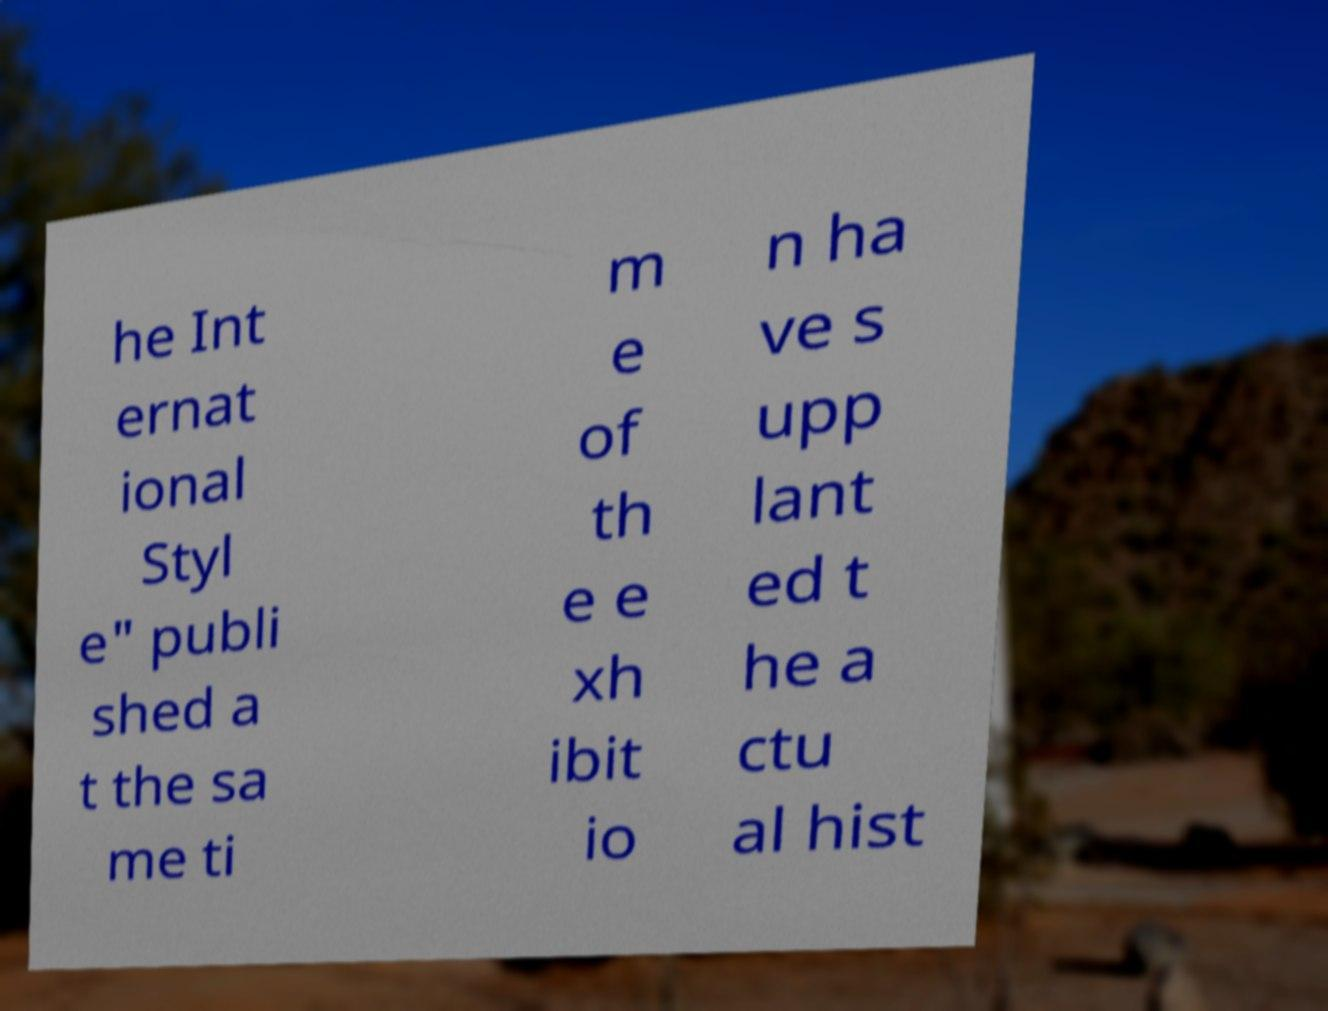Can you accurately transcribe the text from the provided image for me? he Int ernat ional Styl e" publi shed a t the sa me ti m e of th e e xh ibit io n ha ve s upp lant ed t he a ctu al hist 